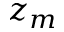Convert formula to latex. <formula><loc_0><loc_0><loc_500><loc_500>z _ { m }</formula> 